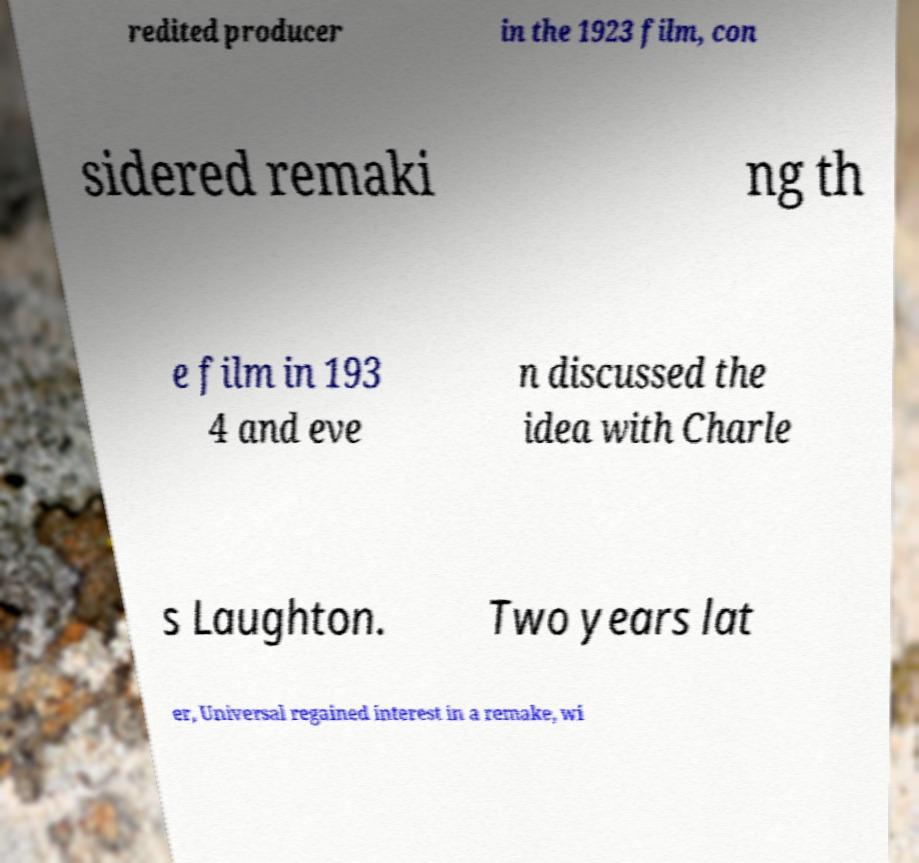Could you assist in decoding the text presented in this image and type it out clearly? redited producer in the 1923 film, con sidered remaki ng th e film in 193 4 and eve n discussed the idea with Charle s Laughton. Two years lat er, Universal regained interest in a remake, wi 